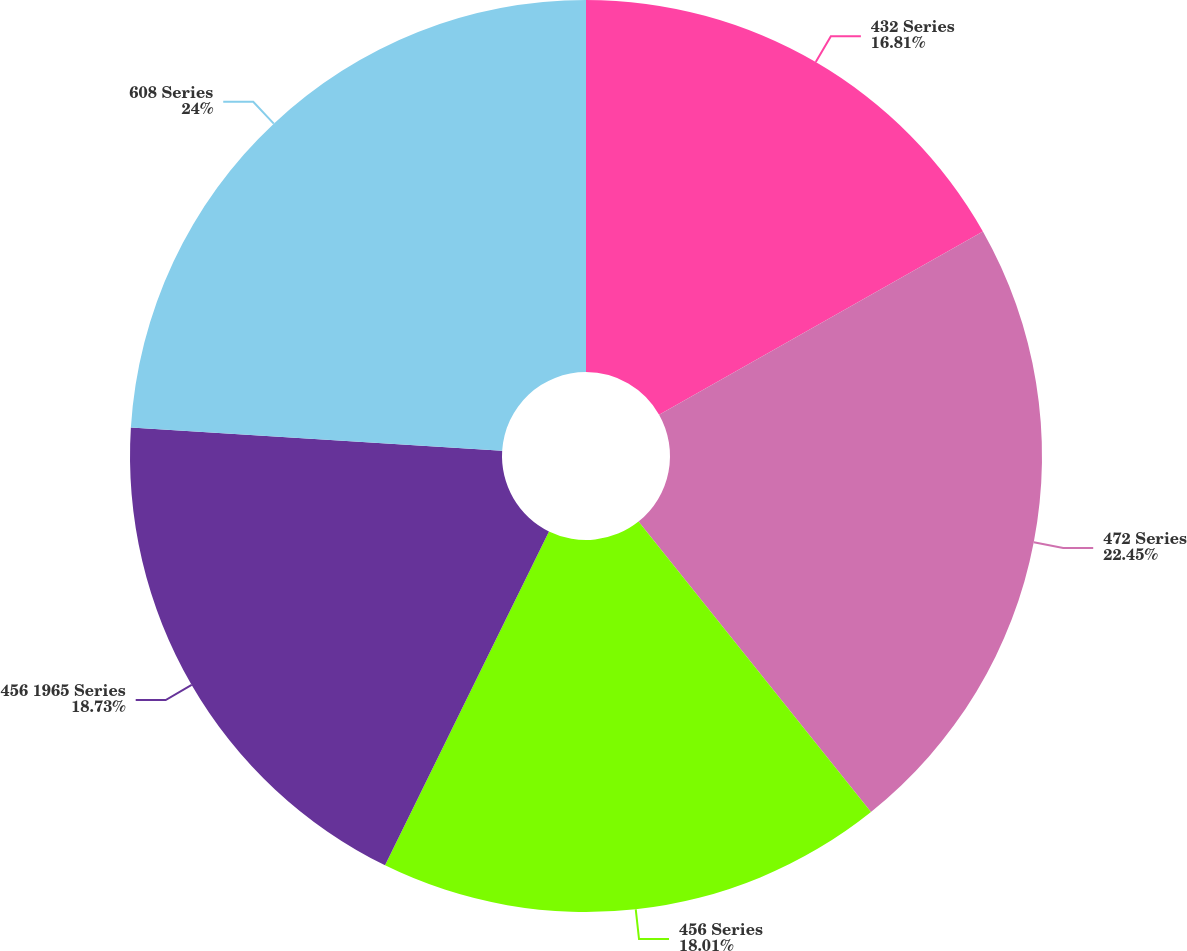<chart> <loc_0><loc_0><loc_500><loc_500><pie_chart><fcel>432 Series<fcel>472 Series<fcel>456 Series<fcel>456 1965 Series<fcel>608 Series<nl><fcel>16.81%<fcel>22.45%<fcel>18.01%<fcel>18.73%<fcel>24.01%<nl></chart> 